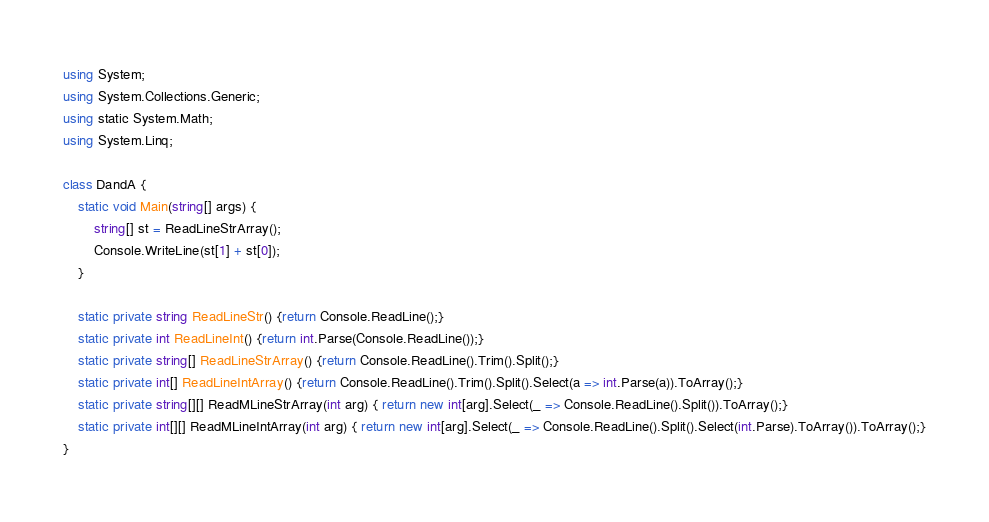Convert code to text. <code><loc_0><loc_0><loc_500><loc_500><_C#_>using System;
using System.Collections.Generic;
using static System.Math;
using System.Linq;
 
class DandA {
    static void Main(string[] args) {
        string[] st = ReadLineStrArray();
        Console.WriteLine(st[1] + st[0]);
    }
  
    static private string ReadLineStr() {return Console.ReadLine();}
    static private int ReadLineInt() {return int.Parse(Console.ReadLine());}
    static private string[] ReadLineStrArray() {return Console.ReadLine().Trim().Split();}
    static private int[] ReadLineIntArray() {return Console.ReadLine().Trim().Split().Select(a => int.Parse(a)).ToArray();}
    static private string[][] ReadMLineStrArray(int arg) { return new int[arg].Select(_ => Console.ReadLine().Split()).ToArray();}
    static private int[][] ReadMLineIntArray(int arg) { return new int[arg].Select(_ => Console.ReadLine().Split().Select(int.Parse).ToArray()).ToArray();}
}</code> 